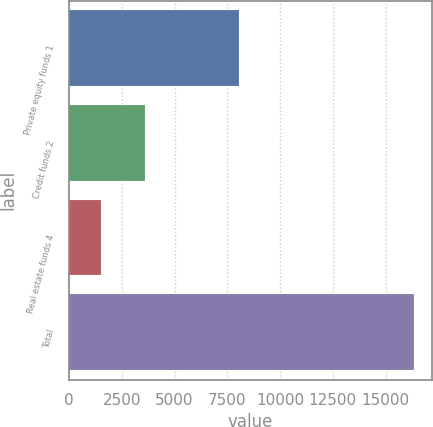Convert chart to OTSL. <chart><loc_0><loc_0><loc_500><loc_500><bar_chart><fcel>Private equity funds 1<fcel>Credit funds 2<fcel>Real estate funds 4<fcel>Total<nl><fcel>8074<fcel>3596<fcel>1531<fcel>16366<nl></chart> 